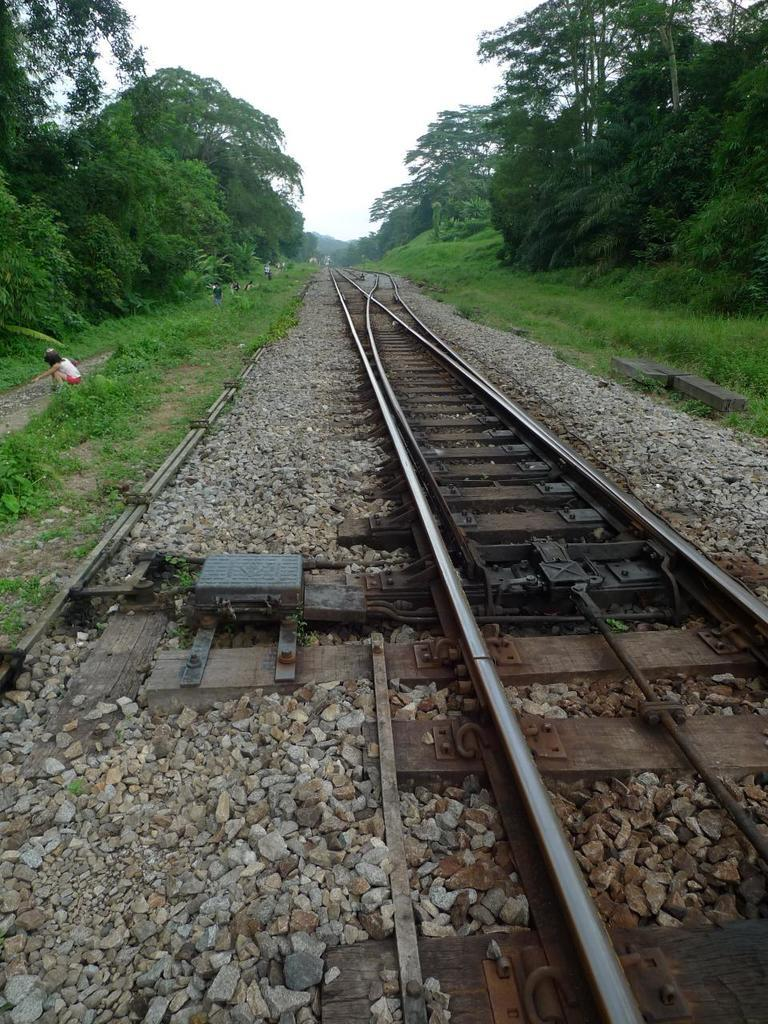What is located in the middle of the image? There are railway tracks in the middle of the image. What can be seen on the left side of the image? There is a person on the left side of the image. What type of vegetation is present on both sides of the image? There are trees on either side of the image. What is visible at the top of the image? The sky is visible at the top of the image. What type of body is the person on the left side of the image competing in? There is no competition present in the image, and therefore no body to compete in. What hand is the person on the left side of the image using to hold a trophy? There is no trophy present in the image, and therefore no hand to hold it. 